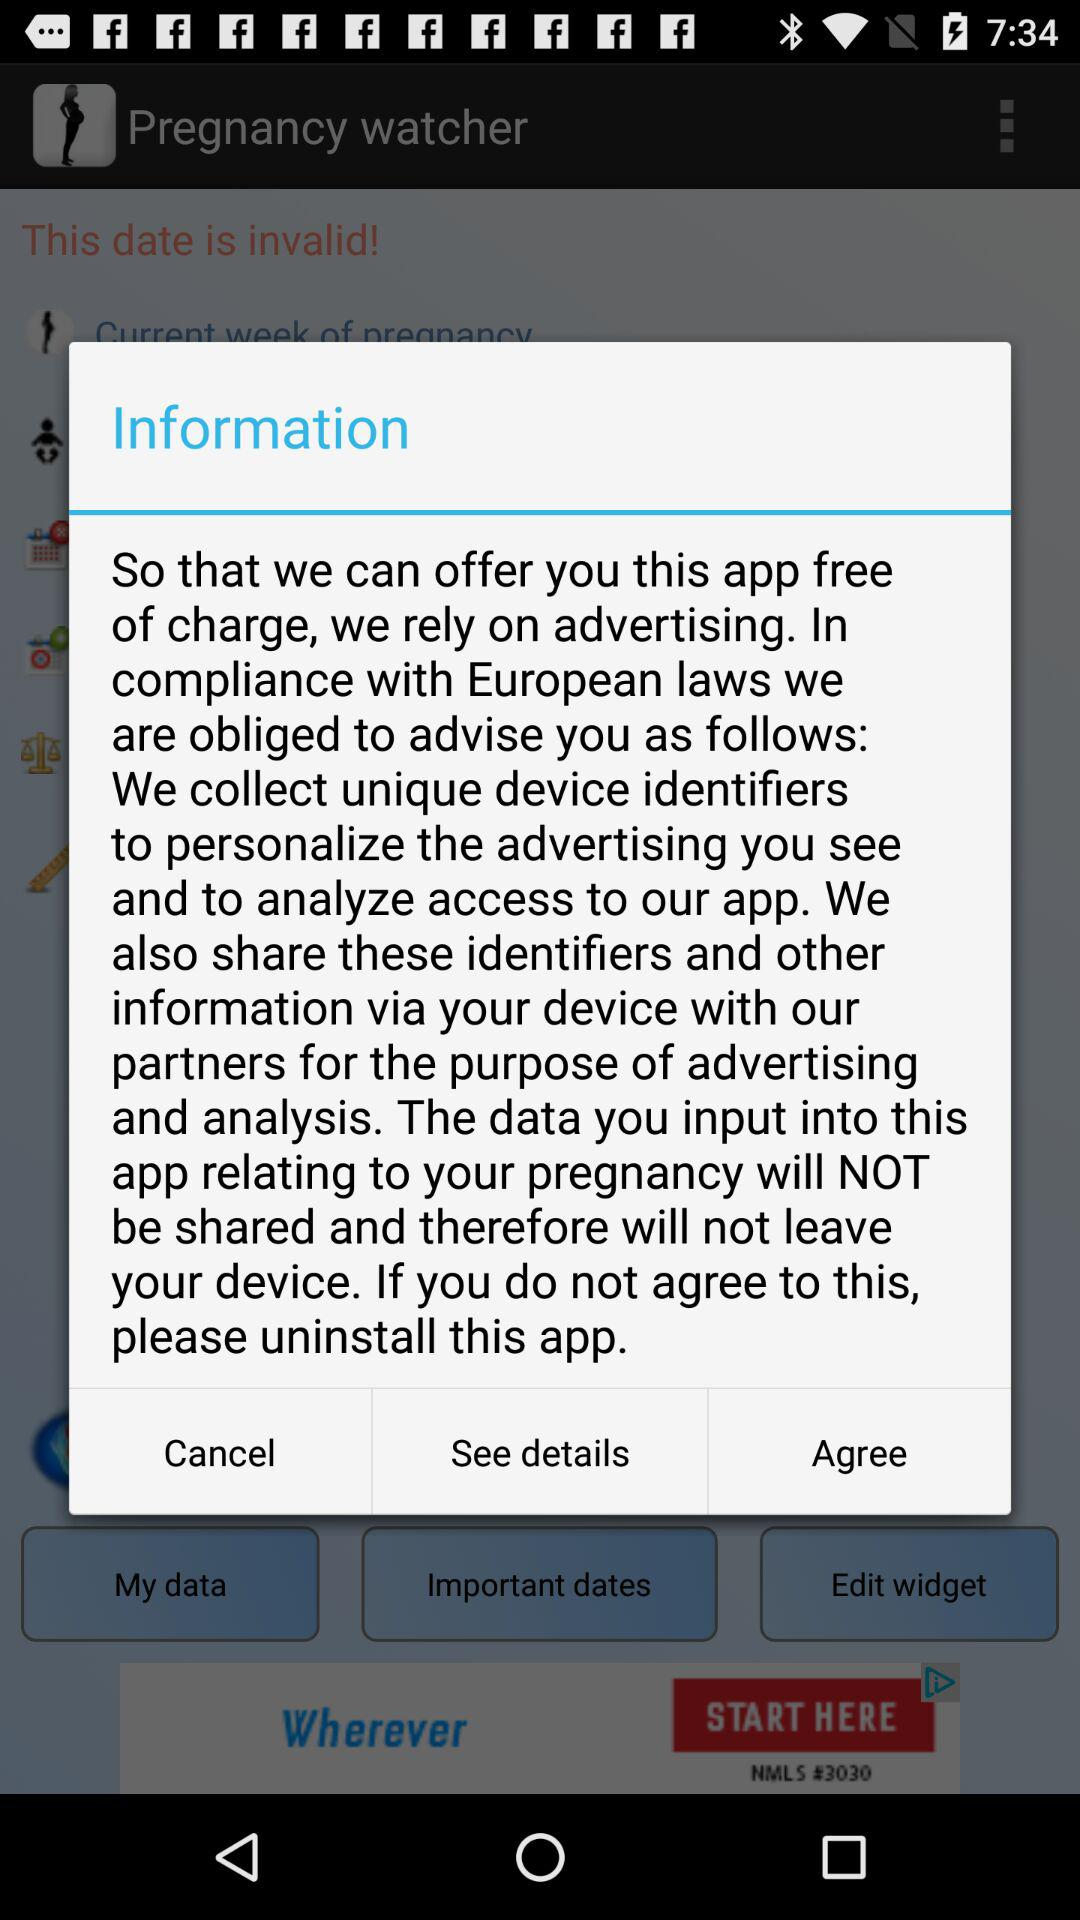What is the application name? The application name is "Pregnancy watcher". 